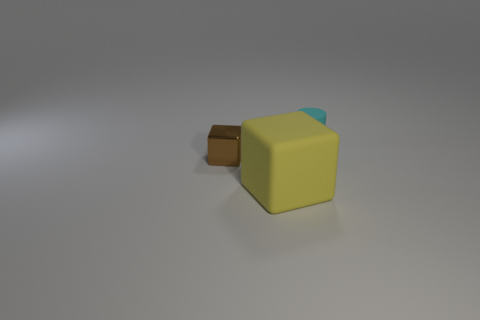Are any tiny brown things visible? Yes, there is a small brown object that appears to be a handle or connector of some sort attached to the larger yellow object in the image. 